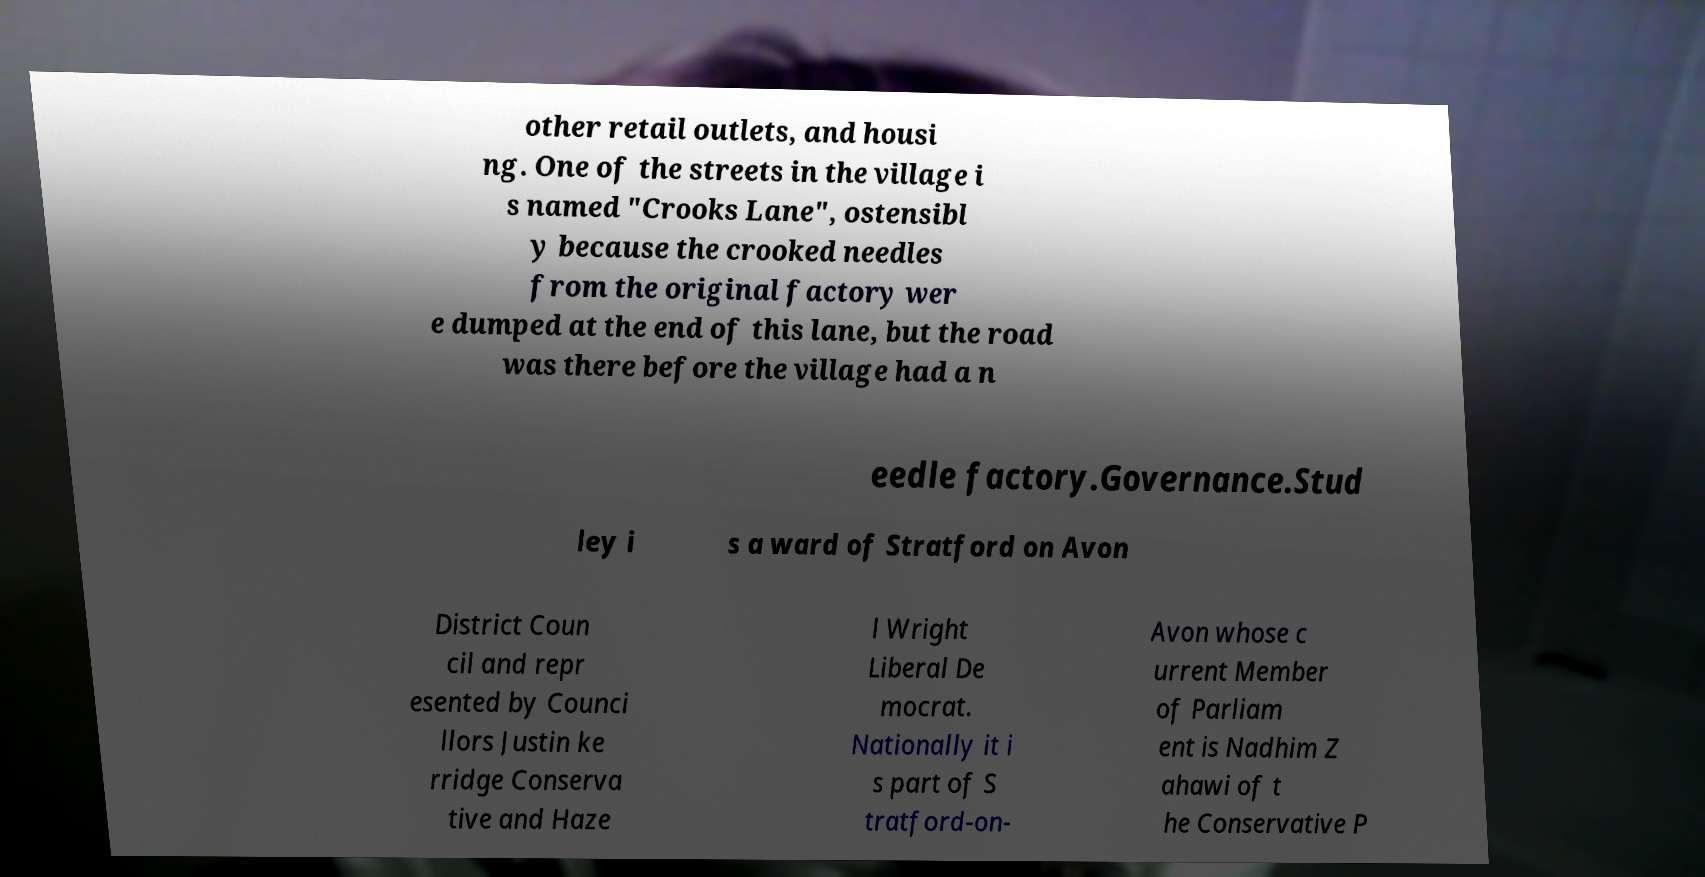Can you accurately transcribe the text from the provided image for me? other retail outlets, and housi ng. One of the streets in the village i s named "Crooks Lane", ostensibl y because the crooked needles from the original factory wer e dumped at the end of this lane, but the road was there before the village had a n eedle factory.Governance.Stud ley i s a ward of Stratford on Avon District Coun cil and repr esented by Counci llors Justin ke rridge Conserva tive and Haze l Wright Liberal De mocrat. Nationally it i s part of S tratford-on- Avon whose c urrent Member of Parliam ent is Nadhim Z ahawi of t he Conservative P 